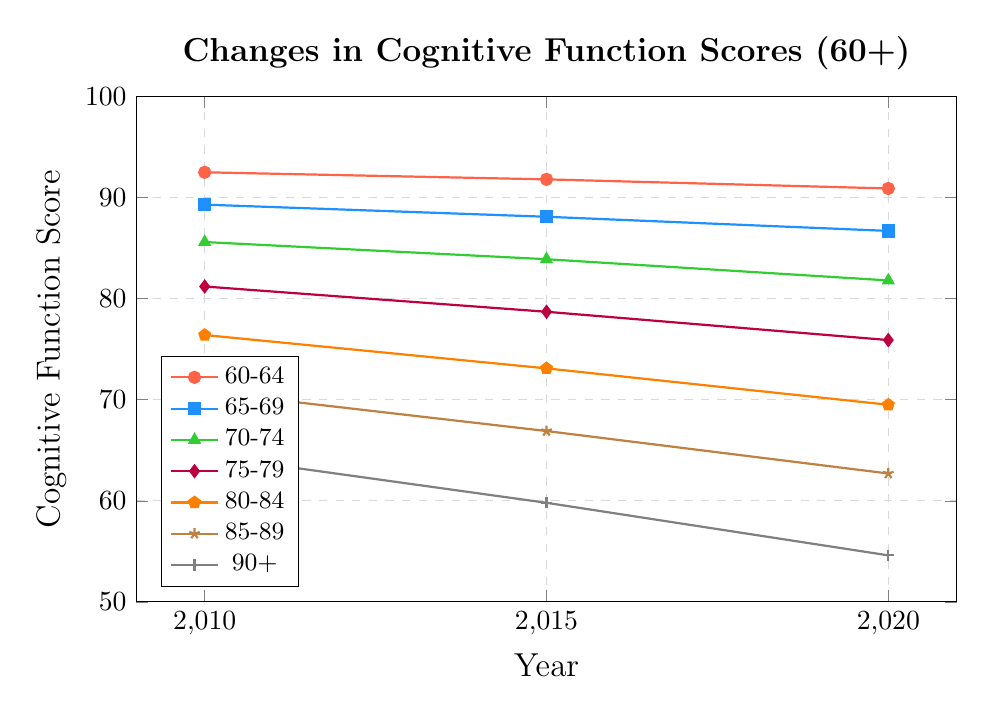What years show the cognitive function scores? The x-axis of the plot indicates the years, which are 2010, 2015, and 2020.
Answer: 2010, 2015, 2020 Which age group shows the highest cognitive function score throughout the years? The 60-64 age group has the highest scores in 2010 (92.5), 2015 (91.8), and 2020 (90.9), as observed in the plot.
Answer: 60-64 Which age group demonstrates the largest decline in cognitive function scores from 2010 to 2020? To determine the largest decline, calculate the differences in scores between 2010 and 2020 for each age group: 60-64 (92.5 - 90.9 = 1.6), 65-69 (89.3 - 86.7 = 2.6), 70-74 (85.6 - 81.8 = 3.8), 75-79 (81.2 - 75.9 = 5.3), 80-84 (76.4 - 69.5 = 6.9), 85-89 (70.8 - 62.7 = 8.1), 90+ (64.5 - 54.6 = 9.9). The 90+ age group has the largest decline.
Answer: 90+ How does the trend in cognitive function scores for the 75-79 age group compare to the 80-84 age group from 2010 to 2020? Both groups show a decreasing trend, but the 75-79 age group decreases from 81.2 in 2010 to 75.9 in 2020 (a decline of 5.3 points), whereas the 80-84 group declines from 76.4 in 2010 to 69.5 in 2020 (a decline of 6.9 points).
Answer: 75-79 decreases by 5.3; 80-84 decreases by 6.9 What is the average cognitive function score for the 70-74 age group over the years? To find the average score for the 70-74 age group, sum the scores and divide by the number of years: (85.6 + 83.9 + 81.8) / 3 = 251.3 / 3.
Answer: 83.8 Which age group crosses below the cognitive function score of 70 in 2020? The plot shows that the 90+ age group has a score of 54.6 in 2020, the 85-89 group has 62.7, and the 80-84 group has 69.5. Only the 90+ and 85-89 age groups have scores below 70.
Answer: 90+, 85-89 Which age group uses purple markers in the plot? By examining the legend, the 75-79 age group is represented by purple diamond markers.
Answer: 75-79 What is the difference in cognitive function scores between the 60-64 and the 90+ age groups in 2015? The score for the 60-64 age group in 2015 is 91.8, while for the 90+ age group it is 59.8. The difference is 91.8 - 59.8.
Answer: 32 